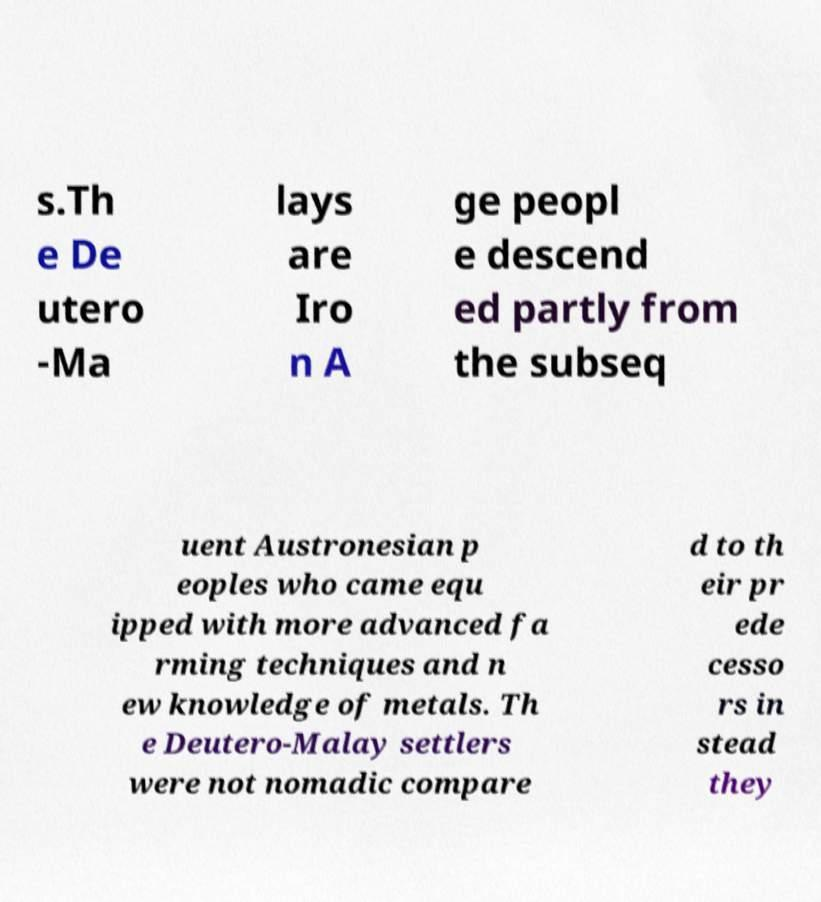Can you accurately transcribe the text from the provided image for me? s.Th e De utero -Ma lays are Iro n A ge peopl e descend ed partly from the subseq uent Austronesian p eoples who came equ ipped with more advanced fa rming techniques and n ew knowledge of metals. Th e Deutero-Malay settlers were not nomadic compare d to th eir pr ede cesso rs in stead they 